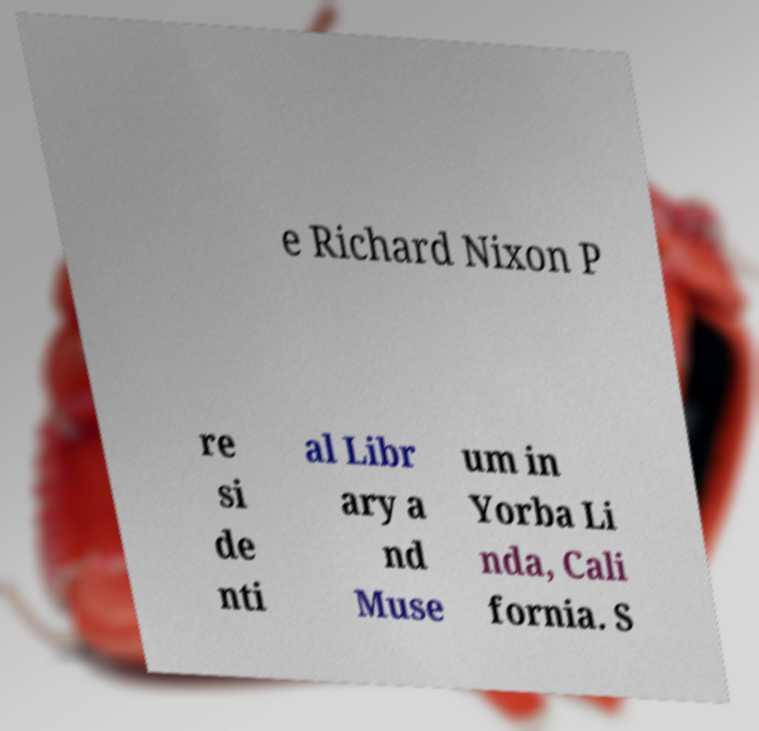Could you assist in decoding the text presented in this image and type it out clearly? e Richard Nixon P re si de nti al Libr ary a nd Muse um in Yorba Li nda, Cali fornia. S 